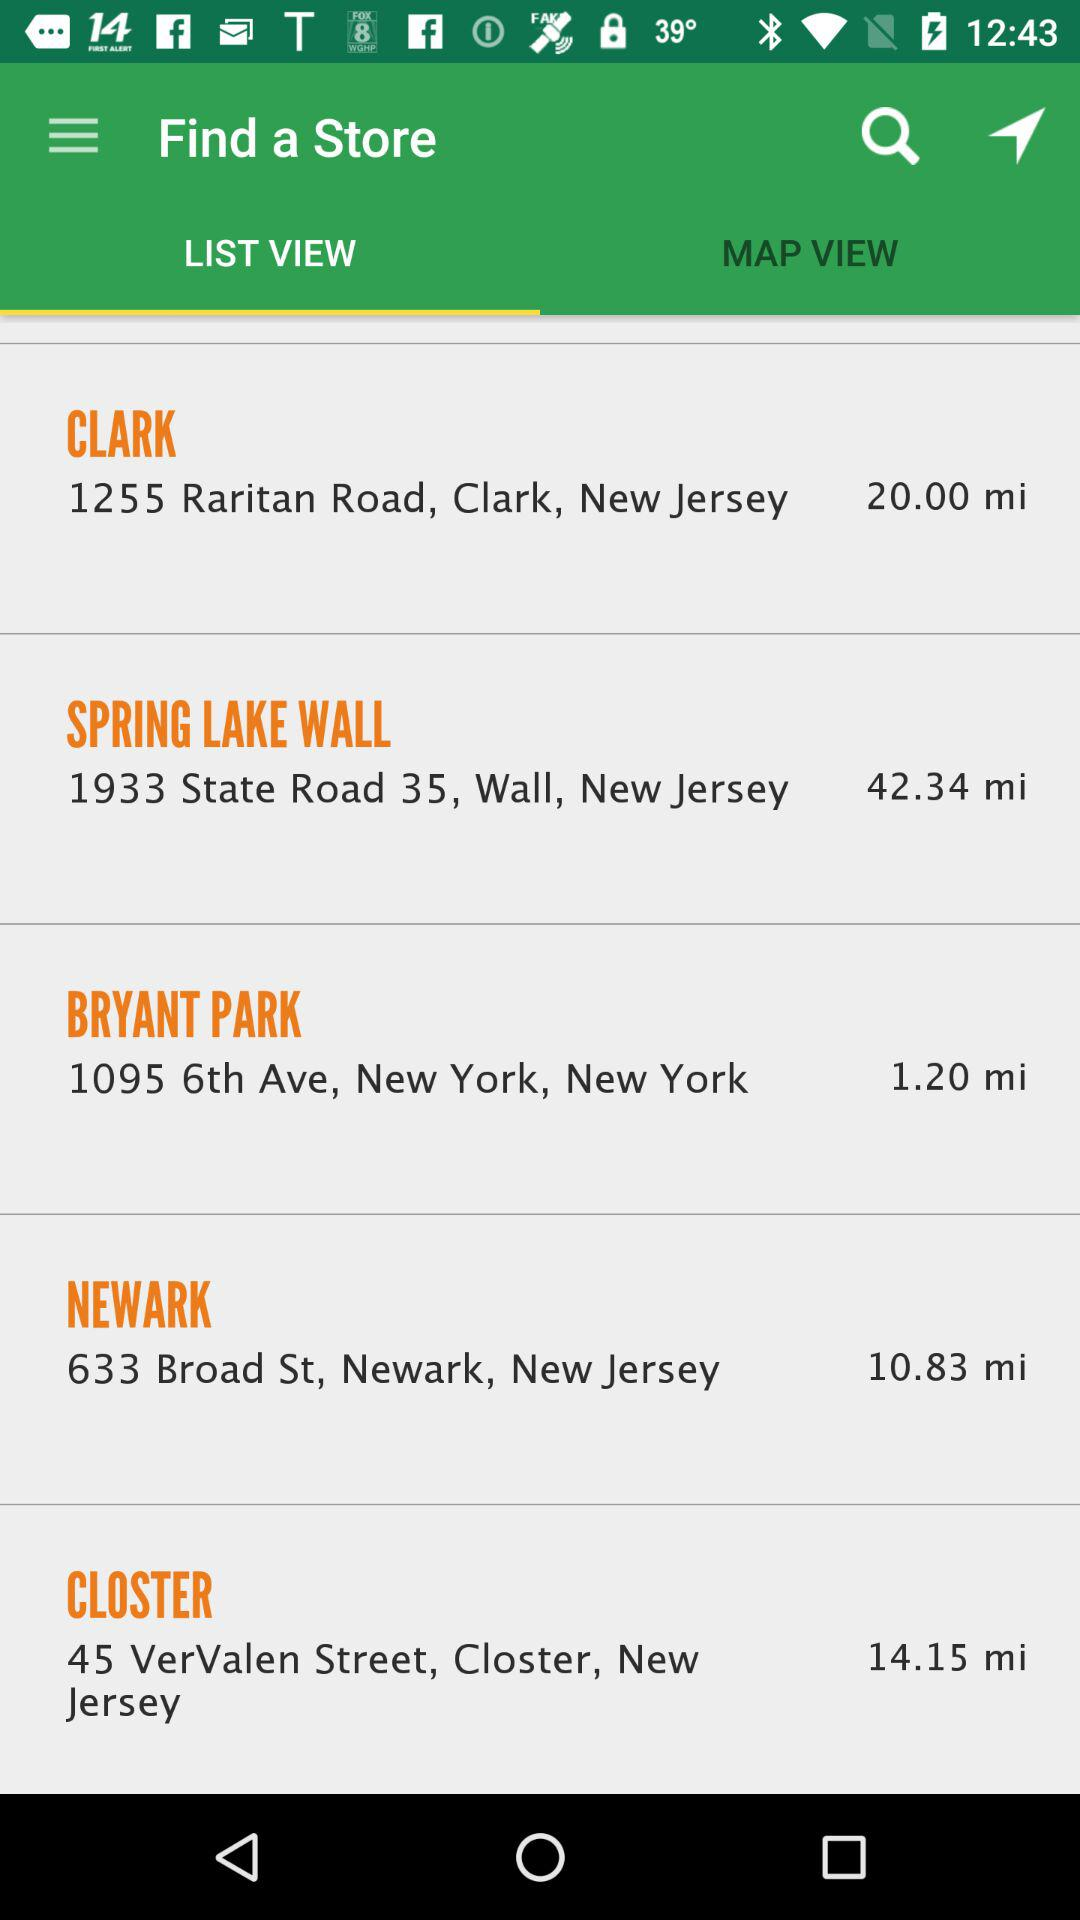What is the selected map view?
When the provided information is insufficient, respond with <no answer>. <no answer> 